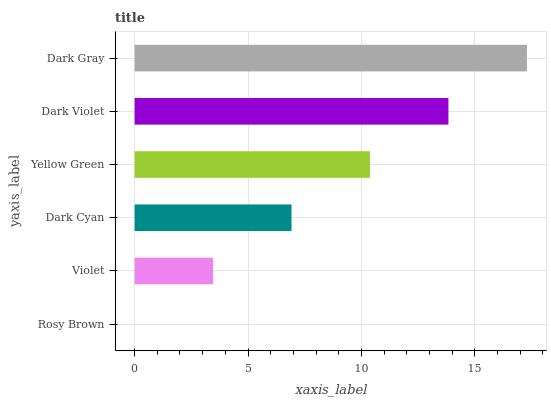Is Rosy Brown the minimum?
Answer yes or no. Yes. Is Dark Gray the maximum?
Answer yes or no. Yes. Is Violet the minimum?
Answer yes or no. No. Is Violet the maximum?
Answer yes or no. No. Is Violet greater than Rosy Brown?
Answer yes or no. Yes. Is Rosy Brown less than Violet?
Answer yes or no. Yes. Is Rosy Brown greater than Violet?
Answer yes or no. No. Is Violet less than Rosy Brown?
Answer yes or no. No. Is Yellow Green the high median?
Answer yes or no. Yes. Is Dark Cyan the low median?
Answer yes or no. Yes. Is Dark Cyan the high median?
Answer yes or no. No. Is Violet the low median?
Answer yes or no. No. 